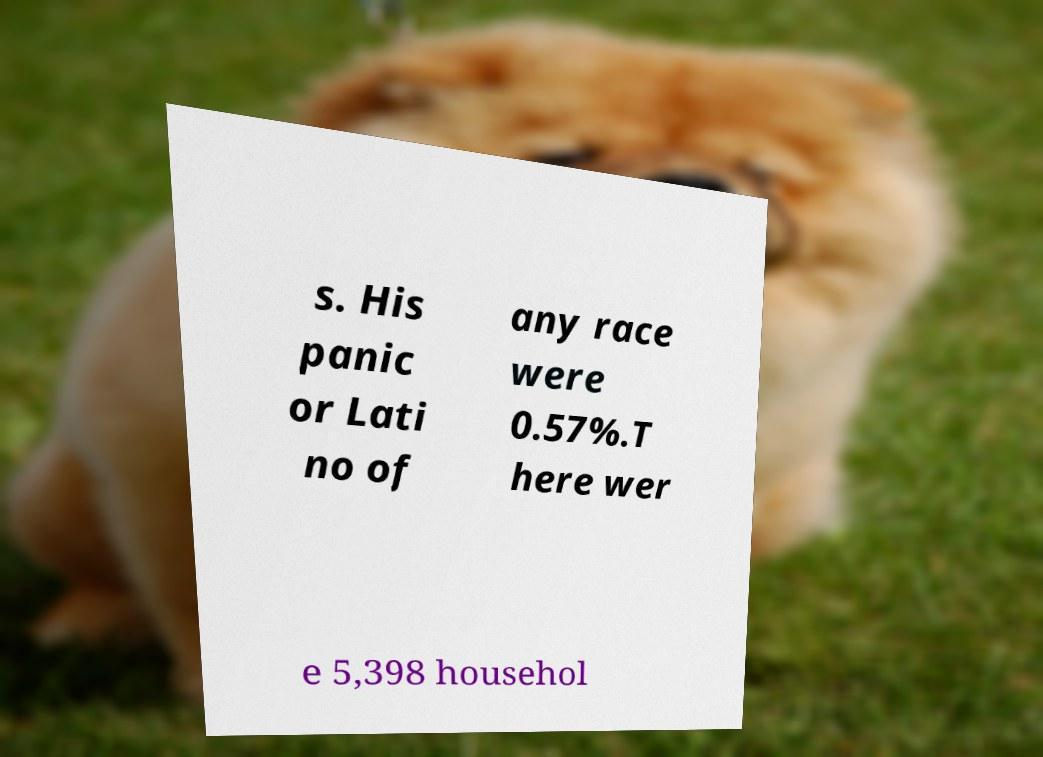Could you assist in decoding the text presented in this image and type it out clearly? s. His panic or Lati no of any race were 0.57%.T here wer e 5,398 househol 